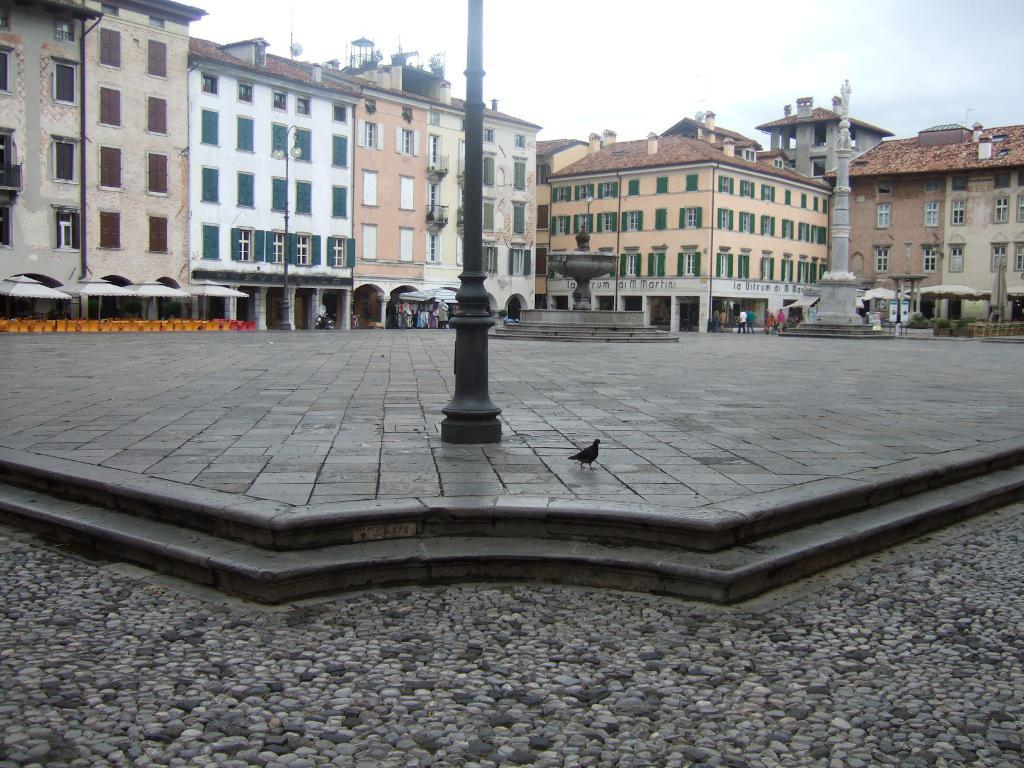What is the main object in the foreground of the image? There is a pole in the image. What type of animal can be seen in the image? There is a bird in the image. What can be seen in the background of the image? There are buildings, people, and poles in the background of the image. What is visible in the sky in the image? The sky is visible in the background of the image. How many pickles are hanging from the pole in the image? There are no pickles present in the image; it features a pole and a bird. What type of dog can be seen interacting with the bird in the image? There is no dog present in the image; it only features a bird and a pole. 